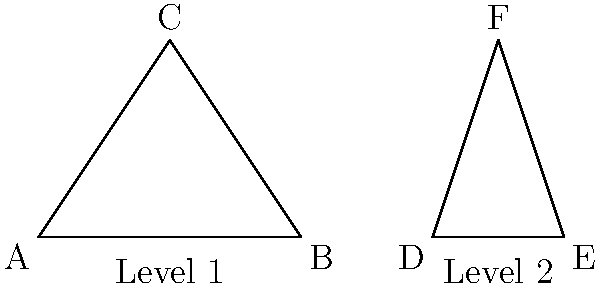In designing balanced game levels using congruent geometric shapes, you've created two triangular platforms for different levels. Given that triangle ABC represents Level 1 and triangle DEF represents Level 2, and that these triangles are congruent, which congruence criterion would you use to prove their congruence if you know that $\overline{AB} \cong \overline{DE}$, $\overline{BC} \cong \overline{EF}$, and $\angle B \cong \angle E$? To prove that triangles ABC and DEF are congruent, we need to use one of the congruence criteria. Let's analyze the given information:

1. We know that $\overline{AB} \cong \overline{DE}$ (one pair of corresponding sides are congruent)
2. We know that $\overline{BC} \cong \overline{EF}$ (another pair of corresponding sides are congruent)
3. We know that $\angle B \cong \angle E$ (one pair of corresponding angles are congruent)

Looking at the congruence criteria:

- SSS (Side-Side-Side): We only have two pairs of congruent sides, not three.
- SAS (Side-Angle-Side): We have two congruent sides and the included angle between them is congruent.
- ASA (Angle-Side-Angle): We only have one pair of congruent angles, not two.
- AAS (Angle-Angle-Side): We only have one pair of congruent angles, not two.
- HL (Hypotenuse-Leg): This is for right triangles, which is not specified in our case.

The criterion that matches our given information is SAS (Side-Angle-Side). We have:
- Side: $\overline{AB} \cong \overline{DE}$
- Angle: $\angle B \cong \angle E$
- Side: $\overline{BC} \cong \overline{EF}$

Therefore, we can use the SAS congruence criterion to prove that triangles ABC and DEF are congruent, ensuring balanced game levels.
Answer: SAS (Side-Angle-Side) 